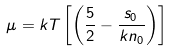<formula> <loc_0><loc_0><loc_500><loc_500>\mu = k T \left [ \left ( \frac { 5 } { 2 } - \frac { s _ { 0 } } { k n _ { 0 } } \right ) \right ]</formula> 